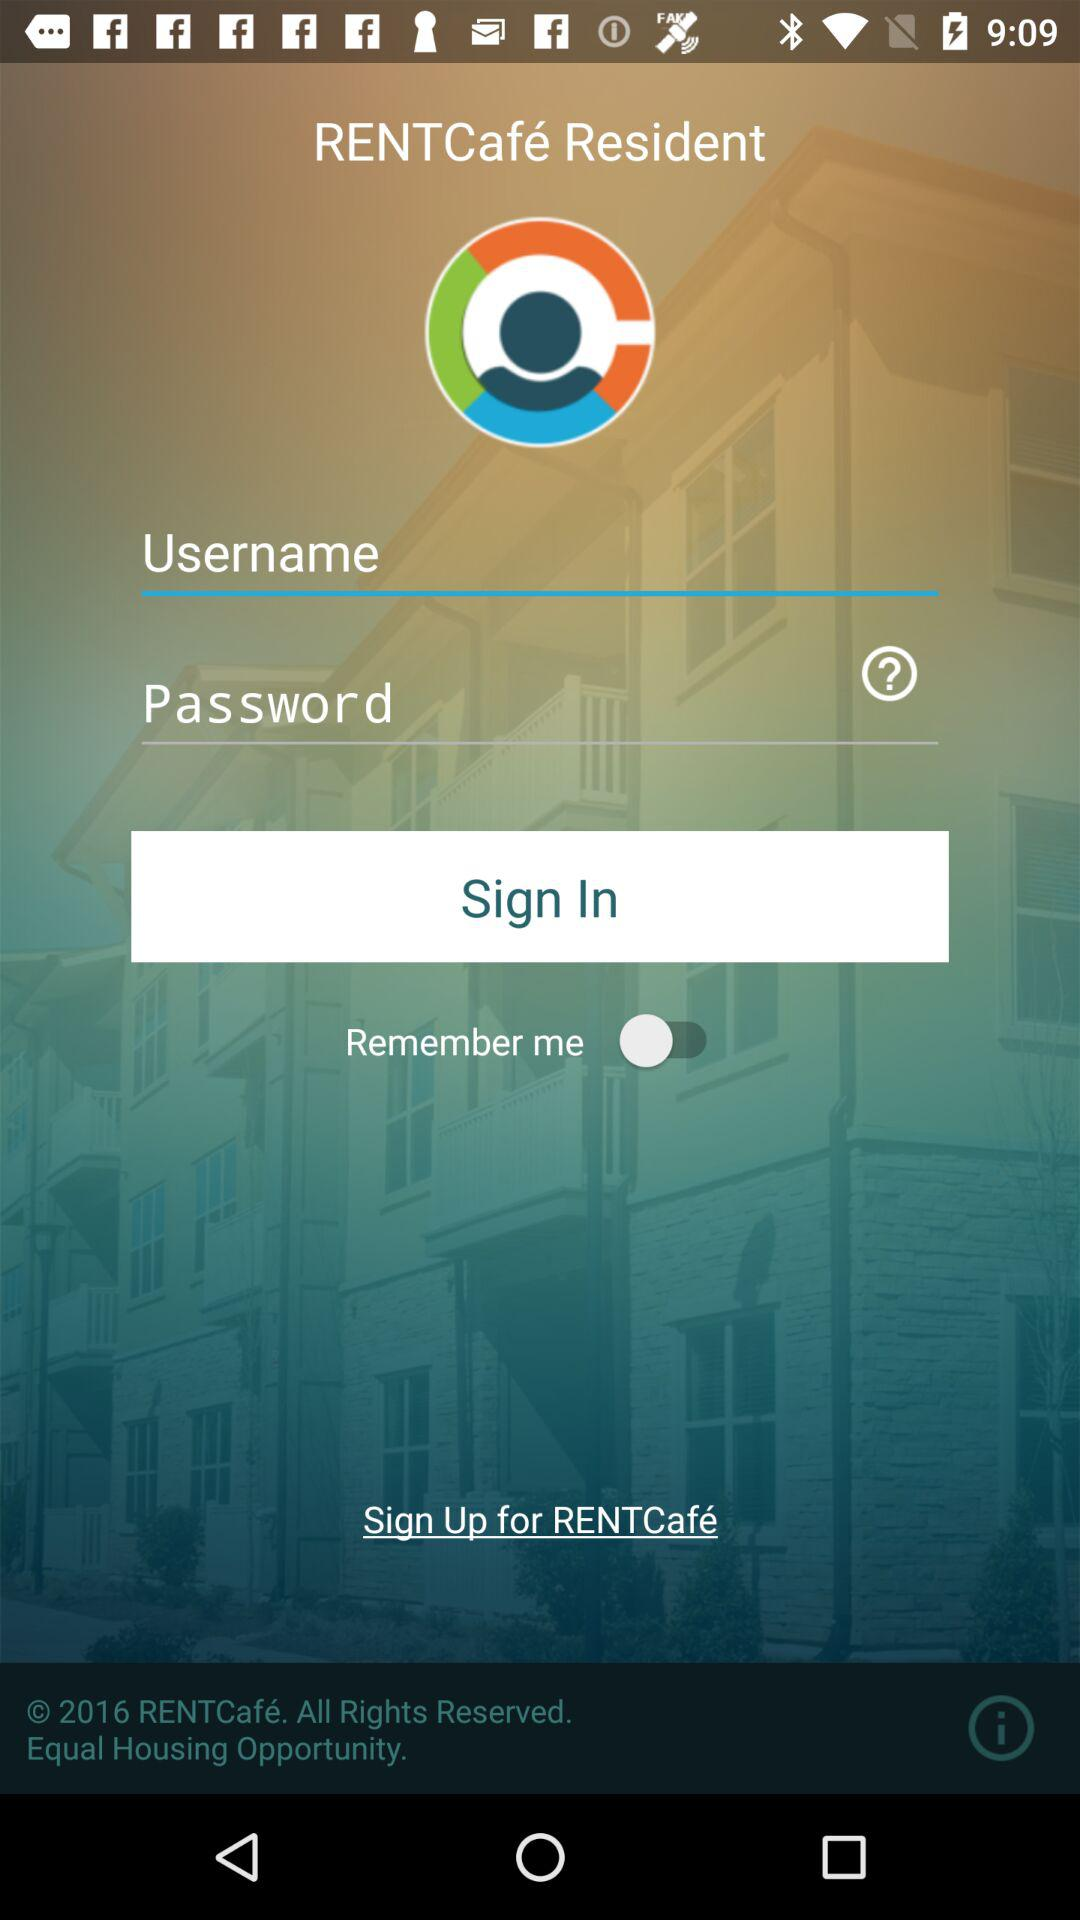What is the application name? The application name is "RENTCafé Resident". 